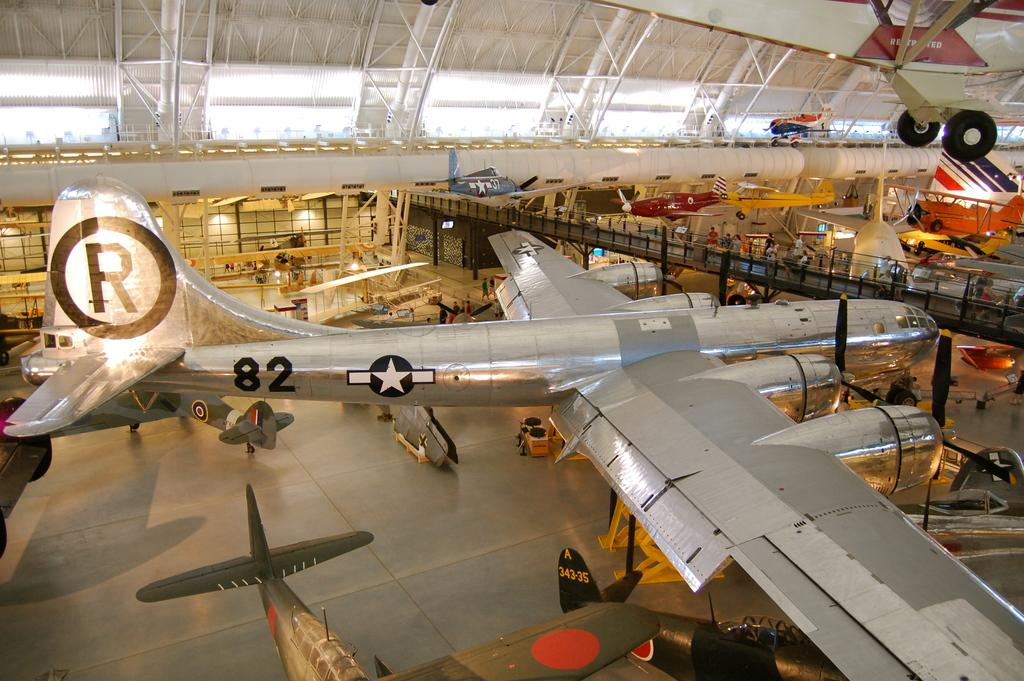<image>
Create a compact narrative representing the image presented. a large airplane hangar with a plane number 82 in it 